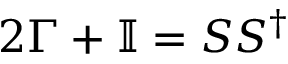Convert formula to latex. <formula><loc_0><loc_0><loc_500><loc_500>2 \Gamma + \mathbb { I } = S S ^ { \dagger }</formula> 